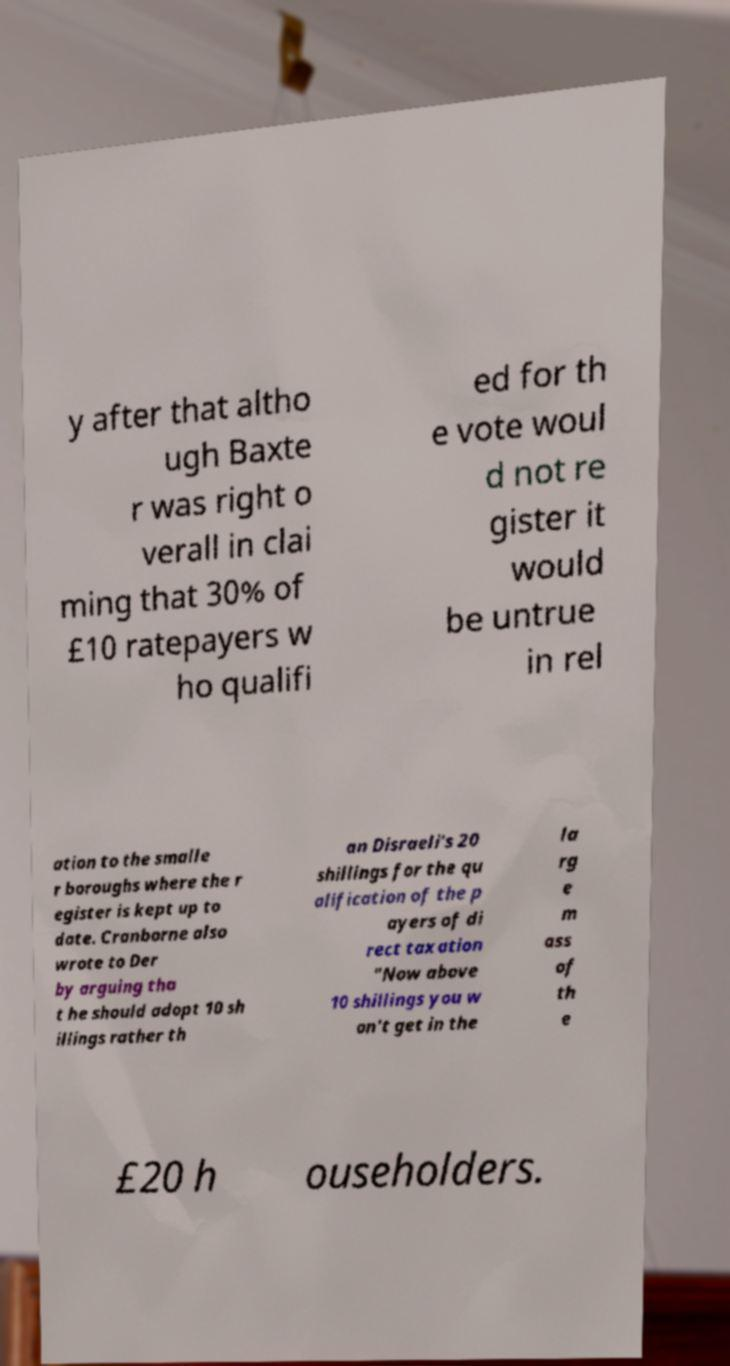Please identify and transcribe the text found in this image. y after that altho ugh Baxte r was right o verall in clai ming that 30% of £10 ratepayers w ho qualifi ed for th e vote woul d not re gister it would be untrue in rel ation to the smalle r boroughs where the r egister is kept up to date. Cranborne also wrote to Der by arguing tha t he should adopt 10 sh illings rather th an Disraeli's 20 shillings for the qu alification of the p ayers of di rect taxation "Now above 10 shillings you w on't get in the la rg e m ass of th e £20 h ouseholders. 